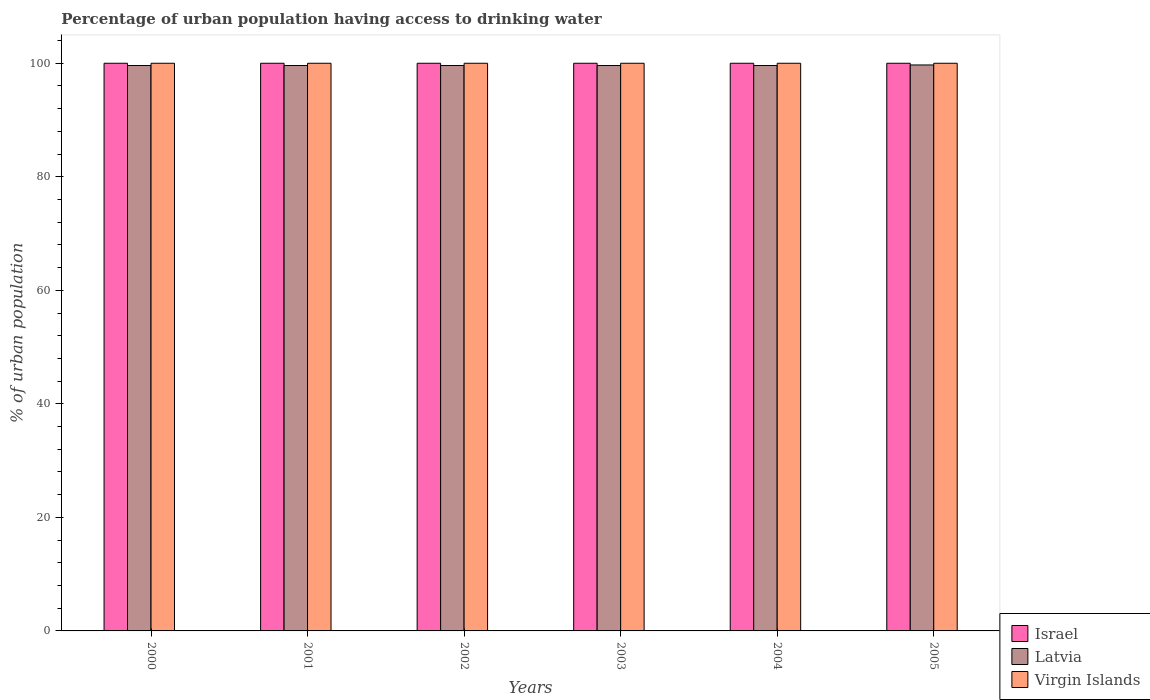How many groups of bars are there?
Your answer should be very brief. 6. How many bars are there on the 1st tick from the left?
Make the answer very short. 3. What is the percentage of urban population having access to drinking water in Latvia in 2002?
Offer a very short reply. 99.6. Across all years, what is the maximum percentage of urban population having access to drinking water in Latvia?
Your response must be concise. 99.7. Across all years, what is the minimum percentage of urban population having access to drinking water in Latvia?
Your answer should be compact. 99.6. In which year was the percentage of urban population having access to drinking water in Israel maximum?
Make the answer very short. 2000. What is the total percentage of urban population having access to drinking water in Israel in the graph?
Make the answer very short. 600. What is the difference between the percentage of urban population having access to drinking water in Latvia in 2003 and the percentage of urban population having access to drinking water in Virgin Islands in 2002?
Your answer should be compact. -0.4. What is the average percentage of urban population having access to drinking water in Latvia per year?
Your answer should be very brief. 99.62. In how many years, is the percentage of urban population having access to drinking water in Virgin Islands greater than 28 %?
Your answer should be very brief. 6. Is the difference between the percentage of urban population having access to drinking water in Virgin Islands in 2002 and 2005 greater than the difference between the percentage of urban population having access to drinking water in Israel in 2002 and 2005?
Offer a terse response. No. What is the difference between the highest and the lowest percentage of urban population having access to drinking water in Virgin Islands?
Your answer should be compact. 0. Is it the case that in every year, the sum of the percentage of urban population having access to drinking water in Israel and percentage of urban population having access to drinking water in Latvia is greater than the percentage of urban population having access to drinking water in Virgin Islands?
Provide a succinct answer. Yes. How many bars are there?
Your response must be concise. 18. How many years are there in the graph?
Offer a very short reply. 6. Does the graph contain grids?
Your response must be concise. No. How are the legend labels stacked?
Offer a very short reply. Vertical. What is the title of the graph?
Offer a terse response. Percentage of urban population having access to drinking water. What is the label or title of the X-axis?
Your answer should be very brief. Years. What is the label or title of the Y-axis?
Offer a terse response. % of urban population. What is the % of urban population in Latvia in 2000?
Make the answer very short. 99.6. What is the % of urban population in Virgin Islands in 2000?
Keep it short and to the point. 100. What is the % of urban population in Latvia in 2001?
Provide a succinct answer. 99.6. What is the % of urban population of Virgin Islands in 2001?
Keep it short and to the point. 100. What is the % of urban population in Israel in 2002?
Your answer should be very brief. 100. What is the % of urban population in Latvia in 2002?
Your response must be concise. 99.6. What is the % of urban population in Israel in 2003?
Your answer should be very brief. 100. What is the % of urban population in Latvia in 2003?
Offer a very short reply. 99.6. What is the % of urban population in Virgin Islands in 2003?
Your answer should be compact. 100. What is the % of urban population in Latvia in 2004?
Your answer should be compact. 99.6. What is the % of urban population in Virgin Islands in 2004?
Provide a short and direct response. 100. What is the % of urban population in Latvia in 2005?
Offer a terse response. 99.7. Across all years, what is the maximum % of urban population in Latvia?
Provide a short and direct response. 99.7. Across all years, what is the maximum % of urban population in Virgin Islands?
Make the answer very short. 100. Across all years, what is the minimum % of urban population in Latvia?
Your answer should be very brief. 99.6. What is the total % of urban population in Israel in the graph?
Ensure brevity in your answer.  600. What is the total % of urban population of Latvia in the graph?
Provide a short and direct response. 597.7. What is the total % of urban population of Virgin Islands in the graph?
Your answer should be very brief. 600. What is the difference between the % of urban population in Israel in 2000 and that in 2001?
Provide a succinct answer. 0. What is the difference between the % of urban population in Latvia in 2000 and that in 2001?
Keep it short and to the point. 0. What is the difference between the % of urban population of Virgin Islands in 2000 and that in 2001?
Offer a terse response. 0. What is the difference between the % of urban population of Israel in 2000 and that in 2002?
Give a very brief answer. 0. What is the difference between the % of urban population in Virgin Islands in 2000 and that in 2002?
Provide a short and direct response. 0. What is the difference between the % of urban population in Latvia in 2000 and that in 2003?
Provide a succinct answer. 0. What is the difference between the % of urban population of Israel in 2000 and that in 2004?
Give a very brief answer. 0. What is the difference between the % of urban population of Latvia in 2000 and that in 2004?
Your answer should be compact. 0. What is the difference between the % of urban population in Virgin Islands in 2000 and that in 2004?
Your response must be concise. 0. What is the difference between the % of urban population of Israel in 2000 and that in 2005?
Your answer should be compact. 0. What is the difference between the % of urban population in Israel in 2001 and that in 2002?
Provide a short and direct response. 0. What is the difference between the % of urban population in Israel in 2001 and that in 2003?
Offer a very short reply. 0. What is the difference between the % of urban population in Latvia in 2001 and that in 2003?
Your answer should be compact. 0. What is the difference between the % of urban population in Israel in 2001 and that in 2004?
Your answer should be very brief. 0. What is the difference between the % of urban population of Virgin Islands in 2001 and that in 2004?
Keep it short and to the point. 0. What is the difference between the % of urban population in Israel in 2001 and that in 2005?
Keep it short and to the point. 0. What is the difference between the % of urban population in Virgin Islands in 2001 and that in 2005?
Your answer should be compact. 0. What is the difference between the % of urban population in Latvia in 2002 and that in 2003?
Your answer should be compact. 0. What is the difference between the % of urban population in Virgin Islands in 2002 and that in 2004?
Provide a succinct answer. 0. What is the difference between the % of urban population in Latvia in 2002 and that in 2005?
Provide a succinct answer. -0.1. What is the difference between the % of urban population of Virgin Islands in 2003 and that in 2004?
Ensure brevity in your answer.  0. What is the difference between the % of urban population of Latvia in 2003 and that in 2005?
Your response must be concise. -0.1. What is the difference between the % of urban population in Virgin Islands in 2003 and that in 2005?
Provide a succinct answer. 0. What is the difference between the % of urban population in Israel in 2000 and the % of urban population in Latvia in 2001?
Your answer should be compact. 0.4. What is the difference between the % of urban population of Israel in 2000 and the % of urban population of Virgin Islands in 2001?
Provide a succinct answer. 0. What is the difference between the % of urban population of Latvia in 2000 and the % of urban population of Virgin Islands in 2001?
Make the answer very short. -0.4. What is the difference between the % of urban population in Israel in 2000 and the % of urban population in Latvia in 2002?
Give a very brief answer. 0.4. What is the difference between the % of urban population in Israel in 2000 and the % of urban population in Virgin Islands in 2002?
Ensure brevity in your answer.  0. What is the difference between the % of urban population in Israel in 2000 and the % of urban population in Virgin Islands in 2003?
Your answer should be very brief. 0. What is the difference between the % of urban population of Israel in 2000 and the % of urban population of Latvia in 2004?
Keep it short and to the point. 0.4. What is the difference between the % of urban population in Israel in 2000 and the % of urban population in Virgin Islands in 2004?
Offer a very short reply. 0. What is the difference between the % of urban population in Latvia in 2000 and the % of urban population in Virgin Islands in 2004?
Make the answer very short. -0.4. What is the difference between the % of urban population of Israel in 2000 and the % of urban population of Latvia in 2005?
Offer a very short reply. 0.3. What is the difference between the % of urban population of Israel in 2000 and the % of urban population of Virgin Islands in 2005?
Keep it short and to the point. 0. What is the difference between the % of urban population of Latvia in 2000 and the % of urban population of Virgin Islands in 2005?
Give a very brief answer. -0.4. What is the difference between the % of urban population of Israel in 2001 and the % of urban population of Latvia in 2003?
Offer a very short reply. 0.4. What is the difference between the % of urban population of Israel in 2001 and the % of urban population of Virgin Islands in 2003?
Offer a very short reply. 0. What is the difference between the % of urban population of Latvia in 2001 and the % of urban population of Virgin Islands in 2004?
Offer a very short reply. -0.4. What is the difference between the % of urban population of Israel in 2001 and the % of urban population of Latvia in 2005?
Keep it short and to the point. 0.3. What is the difference between the % of urban population of Israel in 2001 and the % of urban population of Virgin Islands in 2005?
Offer a terse response. 0. What is the difference between the % of urban population in Israel in 2002 and the % of urban population in Latvia in 2003?
Give a very brief answer. 0.4. What is the difference between the % of urban population in Latvia in 2002 and the % of urban population in Virgin Islands in 2003?
Make the answer very short. -0.4. What is the difference between the % of urban population of Israel in 2002 and the % of urban population of Latvia in 2004?
Keep it short and to the point. 0.4. What is the difference between the % of urban population in Israel in 2002 and the % of urban population in Virgin Islands in 2004?
Your response must be concise. 0. What is the difference between the % of urban population in Israel in 2002 and the % of urban population in Latvia in 2005?
Provide a succinct answer. 0.3. What is the difference between the % of urban population in Israel in 2003 and the % of urban population in Virgin Islands in 2004?
Offer a very short reply. 0. What is the difference between the % of urban population of Latvia in 2003 and the % of urban population of Virgin Islands in 2004?
Provide a short and direct response. -0.4. What is the difference between the % of urban population in Israel in 2003 and the % of urban population in Latvia in 2005?
Your answer should be compact. 0.3. What is the difference between the % of urban population of Israel in 2004 and the % of urban population of Virgin Islands in 2005?
Keep it short and to the point. 0. What is the difference between the % of urban population in Latvia in 2004 and the % of urban population in Virgin Islands in 2005?
Ensure brevity in your answer.  -0.4. What is the average % of urban population in Latvia per year?
Your answer should be compact. 99.62. In the year 2000, what is the difference between the % of urban population of Israel and % of urban population of Virgin Islands?
Offer a very short reply. 0. In the year 2001, what is the difference between the % of urban population of Israel and % of urban population of Latvia?
Ensure brevity in your answer.  0.4. In the year 2001, what is the difference between the % of urban population in Latvia and % of urban population in Virgin Islands?
Offer a terse response. -0.4. In the year 2002, what is the difference between the % of urban population of Latvia and % of urban population of Virgin Islands?
Your response must be concise. -0.4. In the year 2003, what is the difference between the % of urban population in Israel and % of urban population in Latvia?
Your response must be concise. 0.4. In the year 2003, what is the difference between the % of urban population in Latvia and % of urban population in Virgin Islands?
Keep it short and to the point. -0.4. In the year 2004, what is the difference between the % of urban population of Israel and % of urban population of Latvia?
Provide a succinct answer. 0.4. In the year 2004, what is the difference between the % of urban population of Israel and % of urban population of Virgin Islands?
Give a very brief answer. 0. In the year 2004, what is the difference between the % of urban population in Latvia and % of urban population in Virgin Islands?
Ensure brevity in your answer.  -0.4. In the year 2005, what is the difference between the % of urban population in Latvia and % of urban population in Virgin Islands?
Your answer should be very brief. -0.3. What is the ratio of the % of urban population in Virgin Islands in 2000 to that in 2001?
Your answer should be compact. 1. What is the ratio of the % of urban population of Israel in 2000 to that in 2002?
Keep it short and to the point. 1. What is the ratio of the % of urban population of Latvia in 2000 to that in 2002?
Give a very brief answer. 1. What is the ratio of the % of urban population in Israel in 2000 to that in 2003?
Your answer should be very brief. 1. What is the ratio of the % of urban population in Virgin Islands in 2000 to that in 2003?
Offer a terse response. 1. What is the ratio of the % of urban population of Israel in 2000 to that in 2004?
Give a very brief answer. 1. What is the ratio of the % of urban population in Latvia in 2000 to that in 2004?
Give a very brief answer. 1. What is the ratio of the % of urban population of Israel in 2000 to that in 2005?
Offer a very short reply. 1. What is the ratio of the % of urban population of Virgin Islands in 2000 to that in 2005?
Keep it short and to the point. 1. What is the ratio of the % of urban population of Latvia in 2001 to that in 2003?
Offer a very short reply. 1. What is the ratio of the % of urban population in Virgin Islands in 2001 to that in 2004?
Provide a short and direct response. 1. What is the ratio of the % of urban population in Israel in 2001 to that in 2005?
Your answer should be very brief. 1. What is the ratio of the % of urban population in Virgin Islands in 2001 to that in 2005?
Make the answer very short. 1. What is the ratio of the % of urban population of Latvia in 2002 to that in 2003?
Your answer should be very brief. 1. What is the ratio of the % of urban population in Virgin Islands in 2002 to that in 2003?
Provide a succinct answer. 1. What is the ratio of the % of urban population of Virgin Islands in 2002 to that in 2004?
Offer a very short reply. 1. What is the ratio of the % of urban population of Latvia in 2002 to that in 2005?
Your answer should be compact. 1. What is the ratio of the % of urban population in Virgin Islands in 2002 to that in 2005?
Offer a very short reply. 1. What is the ratio of the % of urban population in Virgin Islands in 2003 to that in 2004?
Your answer should be compact. 1. What is the ratio of the % of urban population in Israel in 2003 to that in 2005?
Your answer should be compact. 1. What is the ratio of the % of urban population of Virgin Islands in 2003 to that in 2005?
Offer a terse response. 1. What is the ratio of the % of urban population in Israel in 2004 to that in 2005?
Offer a very short reply. 1. What is the ratio of the % of urban population in Latvia in 2004 to that in 2005?
Give a very brief answer. 1. What is the ratio of the % of urban population in Virgin Islands in 2004 to that in 2005?
Give a very brief answer. 1. What is the difference between the highest and the lowest % of urban population in Israel?
Provide a succinct answer. 0. What is the difference between the highest and the lowest % of urban population of Latvia?
Offer a terse response. 0.1. What is the difference between the highest and the lowest % of urban population in Virgin Islands?
Give a very brief answer. 0. 